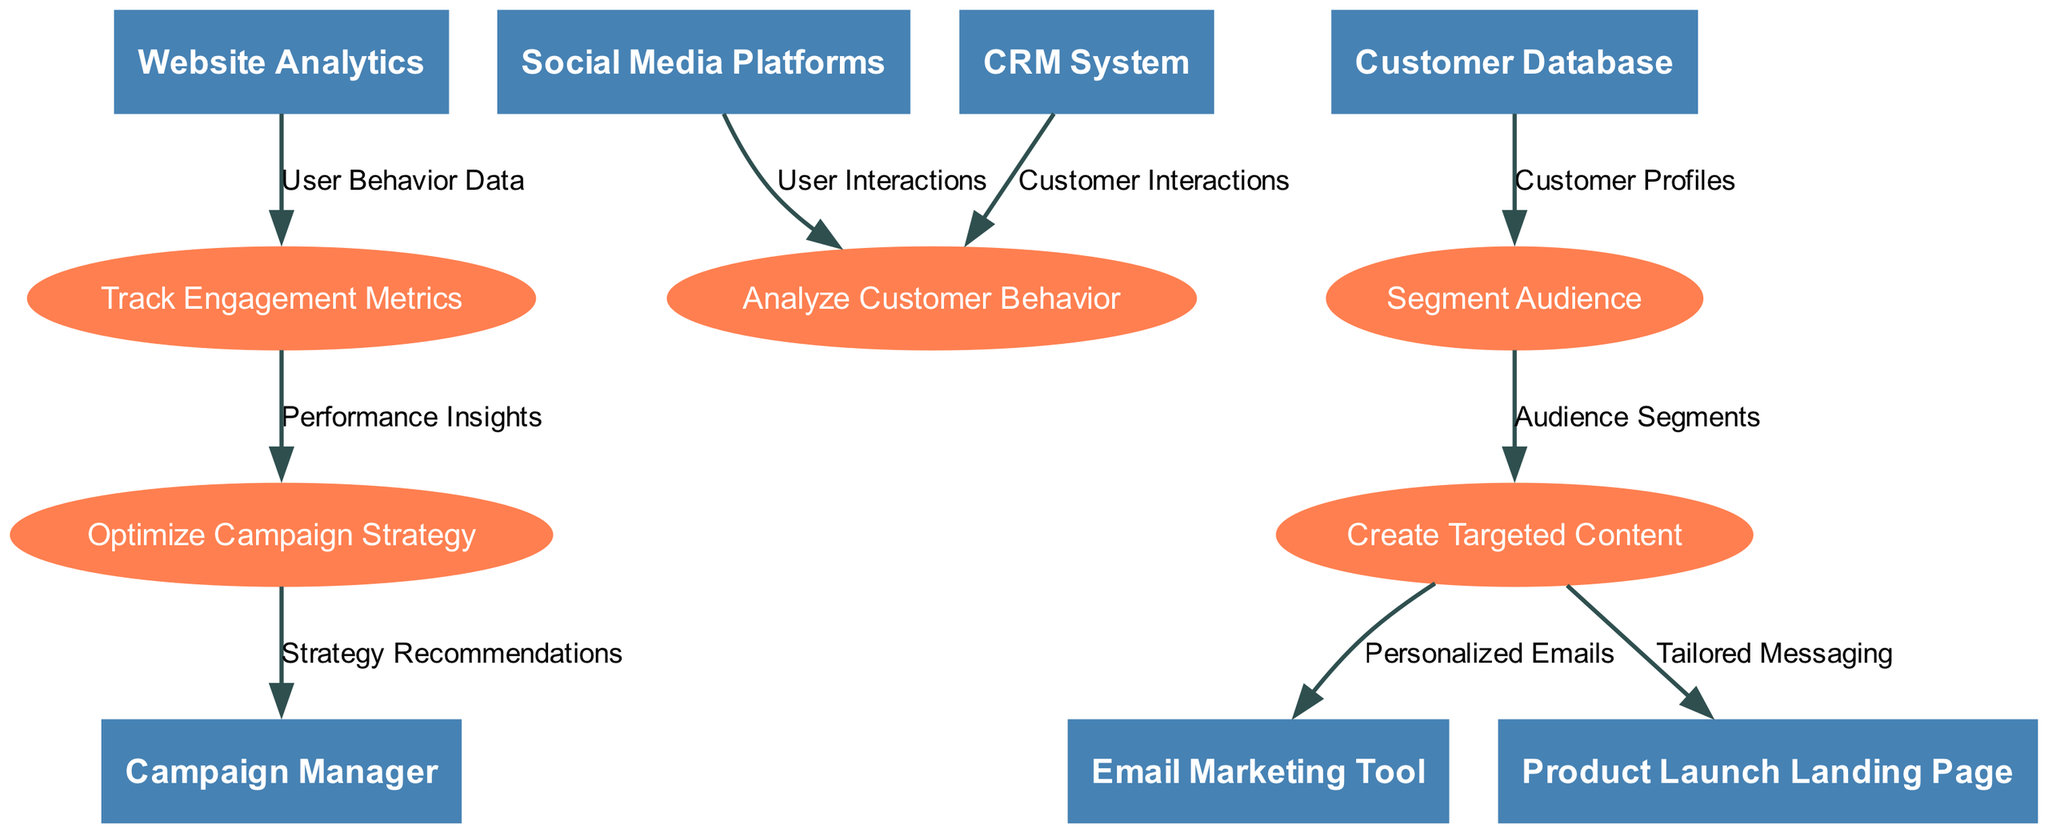What are the entities in the diagram? The entities listed in the diagram are the elements that interact with the processes. They include the Campaign Manager, Social Media Platforms, Customer Database, Email Marketing Tool, Website Analytics, CRM System, and Product Launch Landing Page.
Answer: Campaign Manager, Social Media Platforms, Customer Database, Email Marketing Tool, Website Analytics, CRM System, Product Launch Landing Page How many processes are shown in the diagram? The processes are distinct activities that data flows through in the diagram. The listed processes include Analyze Customer Behavior, Segment Audience, Create Targeted Content, Track Engagement Metrics, and Optimize Campaign Strategy, which totals to five processes.
Answer: 5 What is the data flow from the Social Media Platforms to the Analyze Customer Behavior process? The data flow from Social Media Platforms to the Analyze Customer Behavior process consists of the label "User Interactions," which indicates the specific data being transferred.
Answer: User Interactions Which process receives "Customer Interactions" from the CRM System? The CRM System sends "Customer Interactions" to the Analyze Customer Behavior process, which is responsible for processing this specific data.
Answer: Analyze Customer Behavior What type of data is sent from the Create Targeted Content process to the Email Marketing Tool? The Create Targeted Content process sends "Personalized Emails" to the Email Marketing Tool, which indicates the type of data being transferred for email campaigns.
Answer: Personalized Emails How do the "Performance Insights" inform the Campaign Manager? The "Performance Insights" flow from Track Engagement Metrics to Optimize Campaign Strategy, which then transfers the insights to the Campaign Manager. Thus, they inform strategy recommendations based on campaign performance data.
Answer: Strategy Recommendations What process is directly linked to the "Tailored Messaging"? The "Tailored Messaging" flows from the Create Targeted Content process to the Product Launch Landing Page, indicating that the messaging is customized for that specific landing page.
Answer: Product Launch Landing Page Which process analyzes the "User Behavior Data"? The process that analyzes "User Behavior Data" is Track Engagement Metrics, which utilizes data received from Website Analytics to assess user interactions and behavior.
Answer: Track Engagement Metrics 